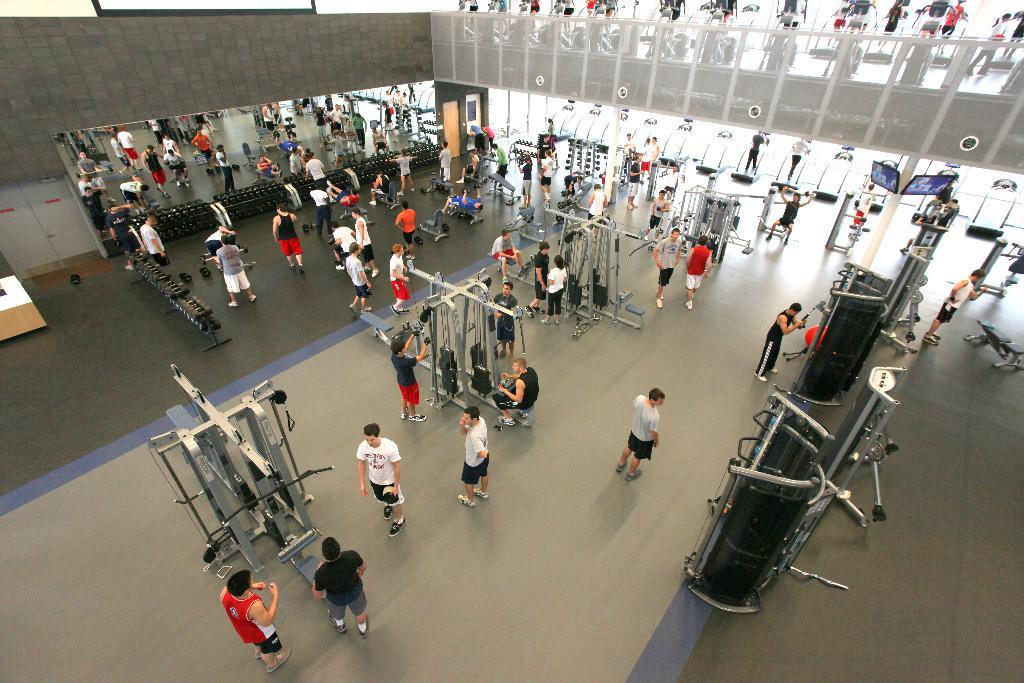What type of location is depicted in the image? The image appears to depict a gym. Can you describe the people in the image? There is a group of people in the image. What can be seen in the gym besides the people? Gym equipment is visible in the image. Where is the grandmother's car parked in the image? There is no car or grandmother present in the image; it depicts a gym with people and gym equipment. How many frogs can be seen on the gym equipment in the image? There are no frogs present in the image; it only features people and gym equipment. 